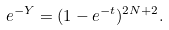Convert formula to latex. <formula><loc_0><loc_0><loc_500><loc_500>e ^ { - Y } = ( 1 - e ^ { - t } ) ^ { 2 N + 2 } .</formula> 